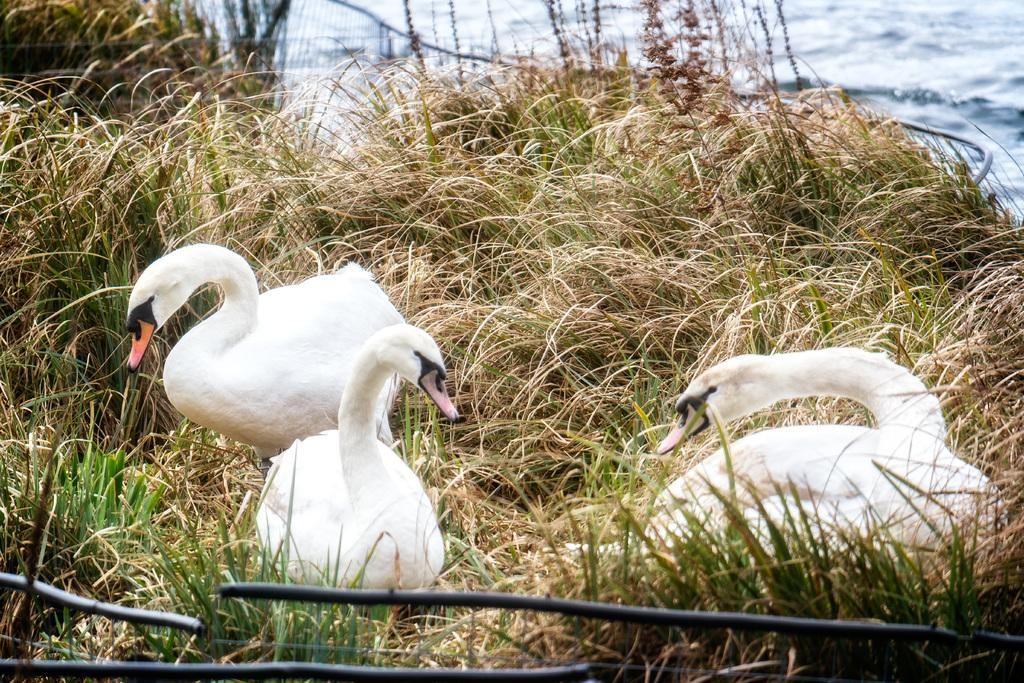How many swans are in the image? There are three Tundra swans in the image. What color are the swans? The swans are white in color. Where are the swans located in the image? The swans are on the grass. What can be seen in the background of the image? There is water visible in the background of the image. What type of meat is being served on the roof in the image? There is no meat or roof present in the image; it features three white Tundra swans on the grass with water visible in the background. 